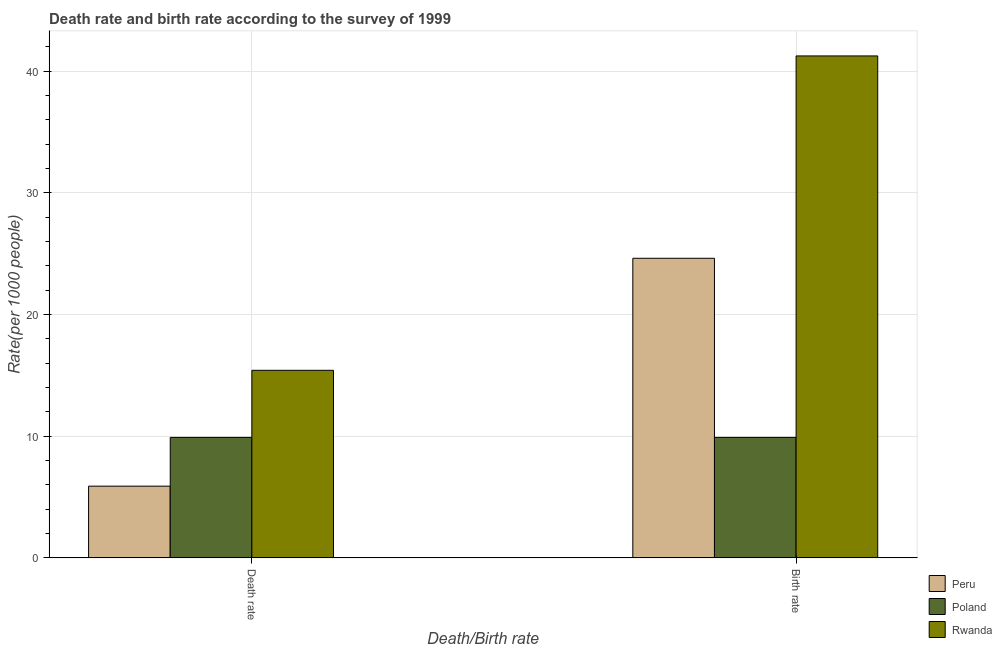How many different coloured bars are there?
Give a very brief answer. 3. Are the number of bars per tick equal to the number of legend labels?
Provide a short and direct response. Yes. Are the number of bars on each tick of the X-axis equal?
Your answer should be compact. Yes. How many bars are there on the 2nd tick from the right?
Keep it short and to the point. 3. What is the label of the 1st group of bars from the left?
Provide a short and direct response. Death rate. What is the birth rate in Poland?
Make the answer very short. 9.9. Across all countries, what is the maximum death rate?
Make the answer very short. 15.41. Across all countries, what is the minimum death rate?
Ensure brevity in your answer.  5.89. In which country was the birth rate maximum?
Provide a short and direct response. Rwanda. In which country was the birth rate minimum?
Your answer should be very brief. Poland. What is the total death rate in the graph?
Offer a terse response. 31.21. What is the difference between the death rate in Rwanda and that in Peru?
Offer a terse response. 9.52. What is the difference between the death rate in Peru and the birth rate in Poland?
Ensure brevity in your answer.  -4.01. What is the average death rate per country?
Offer a terse response. 10.4. What is the difference between the birth rate and death rate in Poland?
Your response must be concise. 0. What is the ratio of the death rate in Peru to that in Poland?
Provide a short and direct response. 0.6. Is the death rate in Peru less than that in Poland?
Your response must be concise. Yes. In how many countries, is the birth rate greater than the average birth rate taken over all countries?
Offer a terse response. 1. How many countries are there in the graph?
Make the answer very short. 3. What is the difference between two consecutive major ticks on the Y-axis?
Offer a very short reply. 10. Does the graph contain grids?
Your response must be concise. Yes. Where does the legend appear in the graph?
Provide a short and direct response. Bottom right. How many legend labels are there?
Offer a very short reply. 3. What is the title of the graph?
Offer a very short reply. Death rate and birth rate according to the survey of 1999. What is the label or title of the X-axis?
Keep it short and to the point. Death/Birth rate. What is the label or title of the Y-axis?
Provide a short and direct response. Rate(per 1000 people). What is the Rate(per 1000 people) of Peru in Death rate?
Your response must be concise. 5.89. What is the Rate(per 1000 people) of Poland in Death rate?
Provide a succinct answer. 9.9. What is the Rate(per 1000 people) in Rwanda in Death rate?
Keep it short and to the point. 15.41. What is the Rate(per 1000 people) in Peru in Birth rate?
Make the answer very short. 24.61. What is the Rate(per 1000 people) of Rwanda in Birth rate?
Keep it short and to the point. 41.24. Across all Death/Birth rate, what is the maximum Rate(per 1000 people) in Peru?
Make the answer very short. 24.61. Across all Death/Birth rate, what is the maximum Rate(per 1000 people) in Poland?
Your answer should be very brief. 9.9. Across all Death/Birth rate, what is the maximum Rate(per 1000 people) of Rwanda?
Make the answer very short. 41.24. Across all Death/Birth rate, what is the minimum Rate(per 1000 people) in Peru?
Your answer should be very brief. 5.89. Across all Death/Birth rate, what is the minimum Rate(per 1000 people) in Rwanda?
Your answer should be very brief. 15.41. What is the total Rate(per 1000 people) of Peru in the graph?
Your response must be concise. 30.51. What is the total Rate(per 1000 people) of Poland in the graph?
Keep it short and to the point. 19.8. What is the total Rate(per 1000 people) of Rwanda in the graph?
Provide a short and direct response. 56.65. What is the difference between the Rate(per 1000 people) in Peru in Death rate and that in Birth rate?
Offer a terse response. -18.72. What is the difference between the Rate(per 1000 people) of Poland in Death rate and that in Birth rate?
Offer a very short reply. 0. What is the difference between the Rate(per 1000 people) in Rwanda in Death rate and that in Birth rate?
Keep it short and to the point. -25.83. What is the difference between the Rate(per 1000 people) of Peru in Death rate and the Rate(per 1000 people) of Poland in Birth rate?
Offer a very short reply. -4. What is the difference between the Rate(per 1000 people) of Peru in Death rate and the Rate(per 1000 people) of Rwanda in Birth rate?
Your answer should be very brief. -35.34. What is the difference between the Rate(per 1000 people) of Poland in Death rate and the Rate(per 1000 people) of Rwanda in Birth rate?
Provide a short and direct response. -31.34. What is the average Rate(per 1000 people) of Peru per Death/Birth rate?
Give a very brief answer. 15.26. What is the average Rate(per 1000 people) in Poland per Death/Birth rate?
Make the answer very short. 9.9. What is the average Rate(per 1000 people) of Rwanda per Death/Birth rate?
Keep it short and to the point. 28.32. What is the difference between the Rate(per 1000 people) of Peru and Rate(per 1000 people) of Poland in Death rate?
Offer a very short reply. -4. What is the difference between the Rate(per 1000 people) in Peru and Rate(per 1000 people) in Rwanda in Death rate?
Your response must be concise. -9.52. What is the difference between the Rate(per 1000 people) in Poland and Rate(per 1000 people) in Rwanda in Death rate?
Offer a very short reply. -5.51. What is the difference between the Rate(per 1000 people) of Peru and Rate(per 1000 people) of Poland in Birth rate?
Provide a short and direct response. 14.71. What is the difference between the Rate(per 1000 people) in Peru and Rate(per 1000 people) in Rwanda in Birth rate?
Your answer should be very brief. -16.62. What is the difference between the Rate(per 1000 people) in Poland and Rate(per 1000 people) in Rwanda in Birth rate?
Provide a short and direct response. -31.34. What is the ratio of the Rate(per 1000 people) of Peru in Death rate to that in Birth rate?
Your answer should be very brief. 0.24. What is the ratio of the Rate(per 1000 people) in Rwanda in Death rate to that in Birth rate?
Your response must be concise. 0.37. What is the difference between the highest and the second highest Rate(per 1000 people) of Peru?
Provide a short and direct response. 18.72. What is the difference between the highest and the second highest Rate(per 1000 people) in Poland?
Your response must be concise. 0. What is the difference between the highest and the second highest Rate(per 1000 people) of Rwanda?
Your answer should be very brief. 25.83. What is the difference between the highest and the lowest Rate(per 1000 people) of Peru?
Offer a terse response. 18.72. What is the difference between the highest and the lowest Rate(per 1000 people) in Rwanda?
Ensure brevity in your answer.  25.83. 